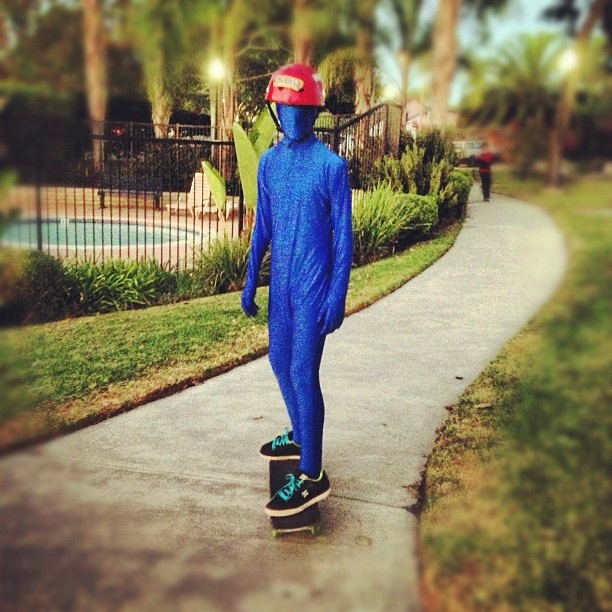Describe the objects in this image and their specific colors. I can see people in olive, darkblue, blue, and navy tones, skateboard in olive, black, maroon, gray, and tan tones, and people in olive, black, maroon, and brown tones in this image. 